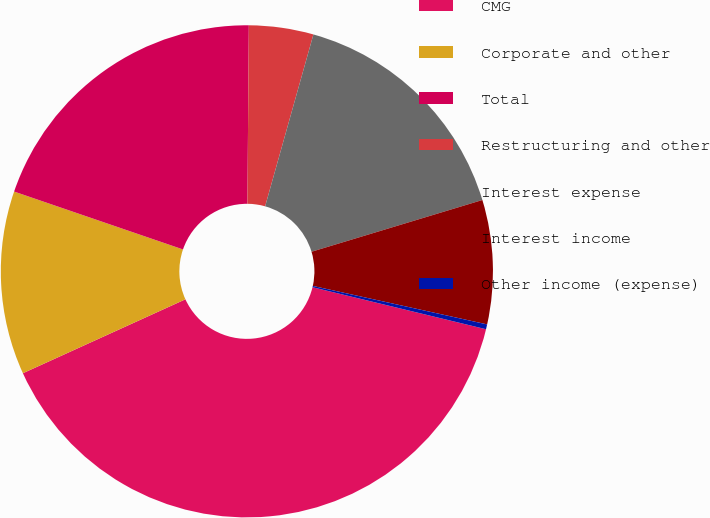Convert chart to OTSL. <chart><loc_0><loc_0><loc_500><loc_500><pie_chart><fcel>CMG<fcel>Corporate and other<fcel>Total<fcel>Restructuring and other<fcel>Interest expense<fcel>Interest income<fcel>Other income (expense)<nl><fcel>39.42%<fcel>12.05%<fcel>19.87%<fcel>4.23%<fcel>15.96%<fcel>8.14%<fcel>0.32%<nl></chart> 